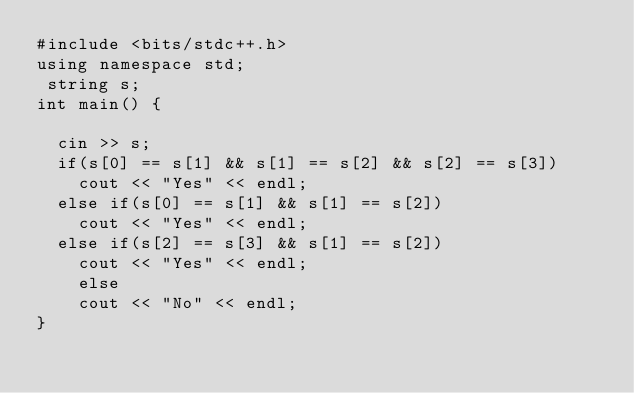Convert code to text. <code><loc_0><loc_0><loc_500><loc_500><_C++_>#include <bits/stdc++.h>
using namespace std;
 string s;
int main() {
 
  cin >> s;
  if(s[0] == s[1] && s[1] == s[2] && s[2] == s[3])
    cout << "Yes" << endl;
  else if(s[0] == s[1] && s[1] == s[2])
    cout << "Yes" << endl;
  else if(s[2] == s[3] && s[1] == s[2])
    cout << "Yes" << endl;
 	else
    cout << "No" << endl;
}</code> 